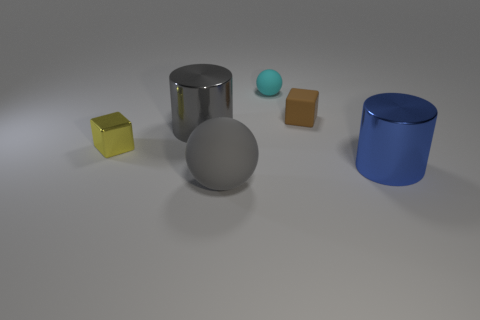How many small things are either gray rubber spheres or matte balls?
Your response must be concise. 1. What is the color of the big rubber object?
Provide a succinct answer. Gray. There is a large shiny cylinder that is on the left side of the small brown rubber cube; is there a big gray sphere that is in front of it?
Your answer should be compact. Yes. Are there fewer big gray balls that are behind the rubber block than tiny blue rubber spheres?
Make the answer very short. No. Do the small object that is on the left side of the tiny sphere and the blue thing have the same material?
Make the answer very short. Yes. The other big cylinder that is made of the same material as the gray cylinder is what color?
Offer a terse response. Blue. Is the number of big spheres that are left of the gray rubber object less than the number of cyan matte things in front of the tiny yellow cube?
Provide a short and direct response. No. There is a cylinder on the left side of the brown cube; is it the same color as the ball that is to the left of the tiny cyan matte object?
Your answer should be compact. Yes. Are there any big blue balls that have the same material as the small yellow thing?
Provide a short and direct response. No. There is a gray object behind the large object that is on the right side of the big rubber ball; how big is it?
Give a very brief answer. Large. 